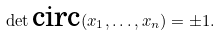<formula> <loc_0><loc_0><loc_500><loc_500>\det \text {circ} ( x _ { 1 } , \dots , x _ { n } ) = \pm 1 .</formula> 